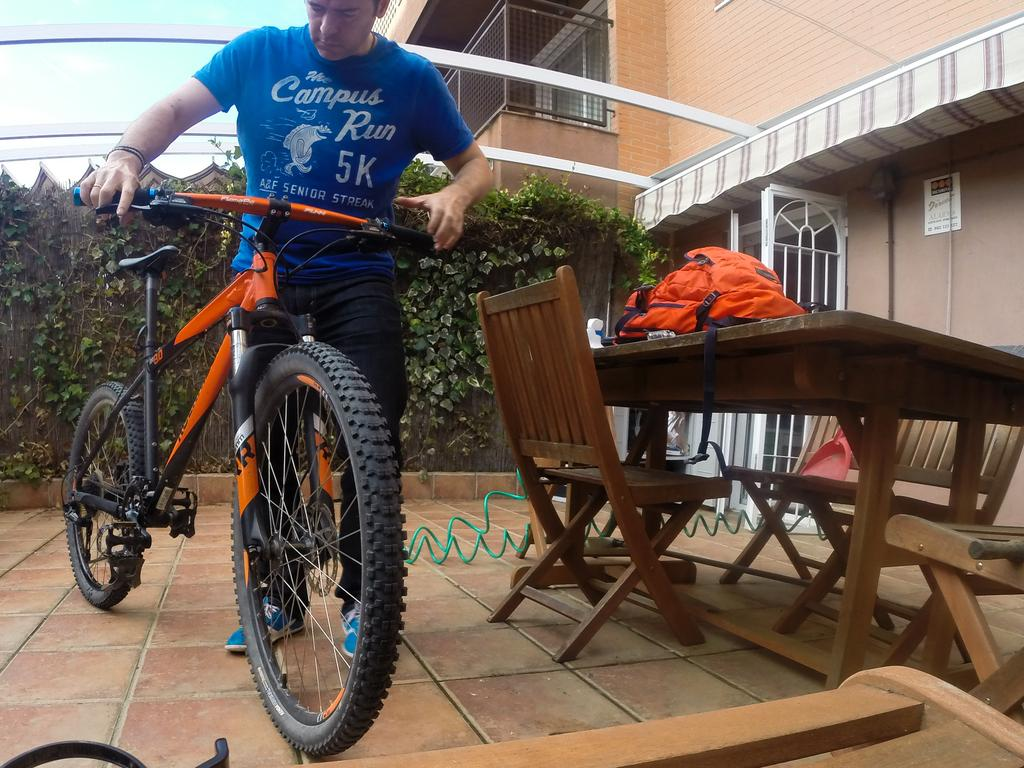What is the man in the image holding? The man is holding a bicycle. What else can be seen on the table in the image? There is a backpack on a table in the image. What type of furniture is present in the image? There are chairs in the image. What is visible in the background of the image? There is a building in the image. What type of vegetation is visible on the man's back? There are plants visible on the man's back. What type of machine is the man using to show his skills in the image? There is no machine present in the image, and the man is not demonstrating any skills. 